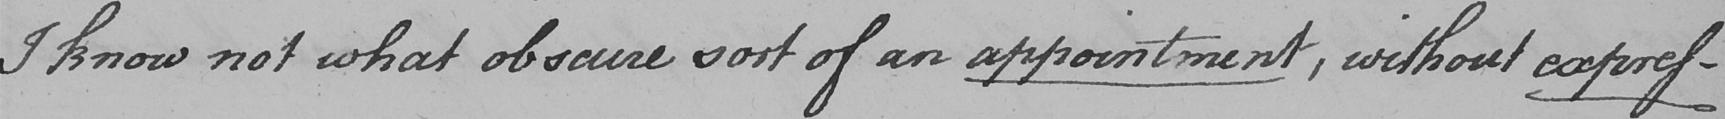What text is written in this handwritten line? I know not what obscure sort of an appointment , without expres- 